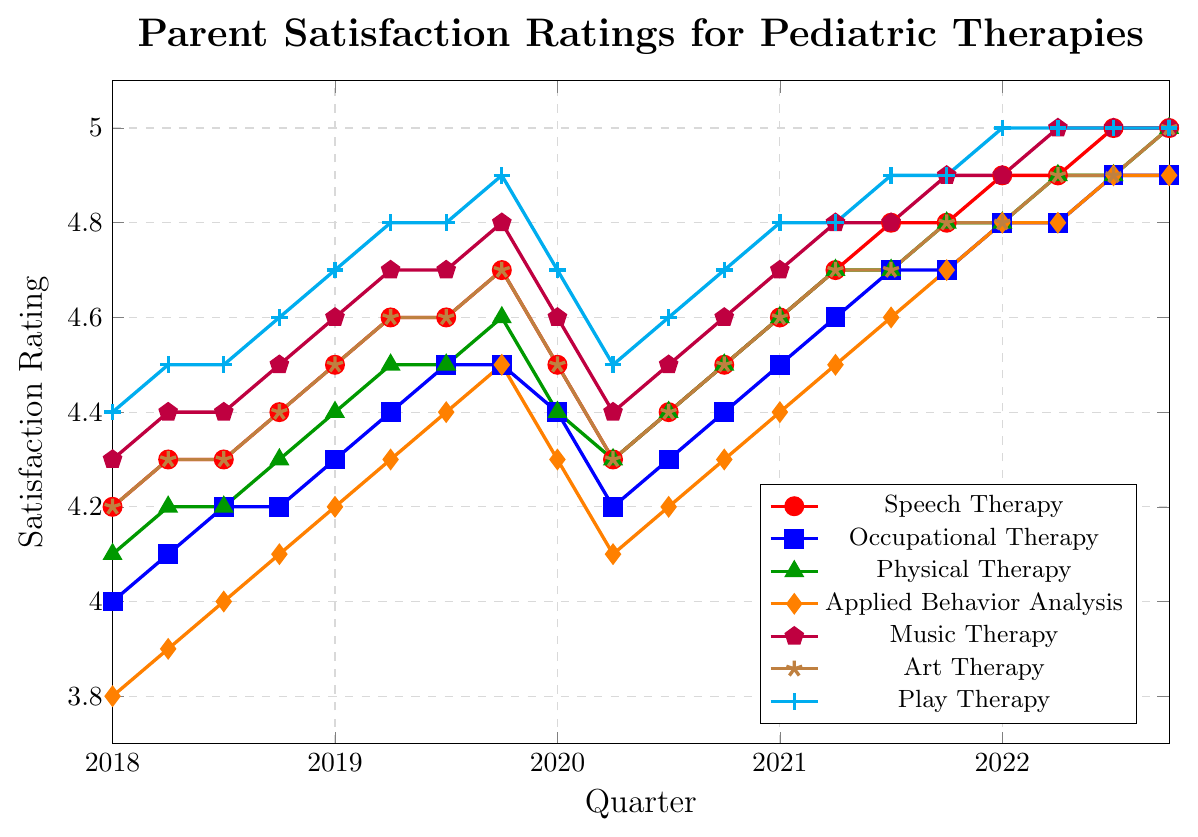What therapy modality had the highest parent satisfaction rating in Q4 2022? Looking at the last data points on the right side of the figure, the ratings for each therapy modality in Q4 2022 are compared. Several therapies including Speech Therapy, Music Therapy, Play Therapy, and Art Therapy all achieve a rating of 5.0.
Answer: Speech Therapy, Music Therapy, Play Therapy, Art Therapy Which therapy modality had the lowest average satisfaction rating in 2018? Calculate the average ratings for each therapy modality for the four quarters in 2018. 
- Speech Therapy: (4.2 + 4.3 + 4.3 + 4.4) / 4 = 4.3
- Occupational Therapy: (4.0 + 4.1 + 4.2 + 4.2) / 4 = 4.125
- Physical Therapy: (4.1 + 4.2 + 4.2 + 4.3) / 4 = 4.2
- Applied Behavior Analysis: (3.8 + 3.9 + 4.0 + 4.1) / 4 = 3.95
- Music Therapy: (4.3 + 4.4 + 4.4 + 4.5) / 4 = 4.4
- Art Therapy: (4.2 + 4.3 + 4.3 + 4.4) / 4 = 4.3
- Play Therapy: (4.4 + 4.5 + 4.5 + 4.6) / 4 = 4.5
The lowest average rating is for Applied Behavior Analysis.
Answer: Applied Behavior Analysis How did the satisfaction ratings for Occupational Therapy change from Q2 2018 to Q1 2019? Speech Therapy had a rating of 4.1 in Q2 2018 and 4.3 in Q1 2019. The change is calculated as 4.3 - 4.1 = 0.2.
Answer: Increased by 0.2 Which therapy modality showed the most improvement from Q4 2019 to Q4 2020? Calculate the change in satisfaction rating for each therapy modality between Q4 2019 and Q4 2020:
- Speech Therapy: 4.5 - 4.7 = -0.2
- Occupational Therapy: 4.4 - 4.5 = -0.1
- Physical Therapy: 4.5 - 4.6 = -0.1
- Applied Behavior Analysis: 4.2 - 4.5 = -0.3
- Music Therapy: 4.5 - 4.8 = -0.3
- Art Therapy: 4.5 - 4.7 = -0.2
- Play Therapy: 4.6 - 4.9 = -0.3
Applied Behavior Analysis improved by 0.2.
Answer: Applied Behavior Analysis Across all therapies, which quarter in 2020 saw the lowest average satisfaction rating? Identify the ratings for each therapy in Q1, Q2, Q3, and Q4 of 2020 and find their averages:
- Q1 2020: (4.5 + 4.4 + 4.4 + 4.3 + 4.6 + 4.5 + 4.7) / 7 = 4.486
- Q2 2020: (4.3 + 4.2 + 4.3 + 4.1 + 4.4 + 4.3 + 4.5) / 7 = 4.257
- Q3 2020: (4.4 + 4.3 + 4.4 + 4.2 + 4.5 + 4.4 + 4.6) / 7 = 4.40
- Q4 2020: (4.5 + 4.4 + 4.5 + 4.3 + 4.6 + 4.5 + 4.7) / 7 = 4.50
Q2 2020 has the lowest average satisfaction rating.
Answer: Q2 2020 What is the trend in Music Therapy satisfaction ratings from Q1 2020 to Q4 2022? By reviewing the Music Therapy ratings from Q1 2020 to Q4 2022: 4.6, 4.4, 4.5, 4.6, 4.7, 4.8, 4.8, 4.9, 4.9, 5.0. The trend shows a consistent increase after an initial drop in Q2 2020.
Answer: Increasing What was the median satisfaction rating for Speech Therapy throughout 2021? The Speech Therapy satisfaction ratings for 2021 are 4.6 (Q1), 4.7 (Q2), 4.8 (Q3), 4.8 (Q4). Arrange the data in ascending order and find the middle value (since there is an even number of data points, the median is the average of the two middle values).
Median = (4.7 + 4.8) / 2 = 4.75.
Answer: 4.75 Which quarter in 2022 had the highest average satisfaction rating across all therapies? Calculate the average ratings for each quarter in 2022:
- Q1 2022: (4.9 + 4.8 + 4.8 + 4.8 + 4.9 + 4.8 + 5.0) / 7 = 4.857
- Q2 2022: (4.9 + 4.8 + 4.9 + 4.8 + 5.0 + 4.9 + 5.0) / 7 = 4.900
- Q3 2022: (5.0 + 4.9 + 4.9 + 4.9 + 5.0 + 4.9 + 5.0) / 7 = 4.943
- Q4 2022: (5.0 + 4.9 + 5.0 + 4.9 + 5.0 + 4.9 + 5.0) / 7 = 4.971
The quarter with the highest average satisfaction rating is Q4 2022.
Answer: Q4 2022 